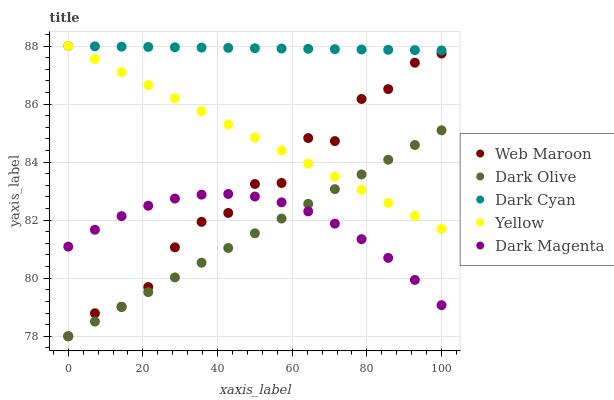Does Dark Olive have the minimum area under the curve?
Answer yes or no. Yes. Does Dark Cyan have the maximum area under the curve?
Answer yes or no. Yes. Does Web Maroon have the minimum area under the curve?
Answer yes or no. No. Does Web Maroon have the maximum area under the curve?
Answer yes or no. No. Is Dark Cyan the smoothest?
Answer yes or no. Yes. Is Web Maroon the roughest?
Answer yes or no. Yes. Is Dark Olive the smoothest?
Answer yes or no. No. Is Dark Olive the roughest?
Answer yes or no. No. Does Dark Olive have the lowest value?
Answer yes or no. Yes. Does Dark Magenta have the lowest value?
Answer yes or no. No. Does Yellow have the highest value?
Answer yes or no. Yes. Does Dark Olive have the highest value?
Answer yes or no. No. Is Web Maroon less than Dark Cyan?
Answer yes or no. Yes. Is Dark Cyan greater than Dark Magenta?
Answer yes or no. Yes. Does Web Maroon intersect Yellow?
Answer yes or no. Yes. Is Web Maroon less than Yellow?
Answer yes or no. No. Is Web Maroon greater than Yellow?
Answer yes or no. No. Does Web Maroon intersect Dark Cyan?
Answer yes or no. No. 